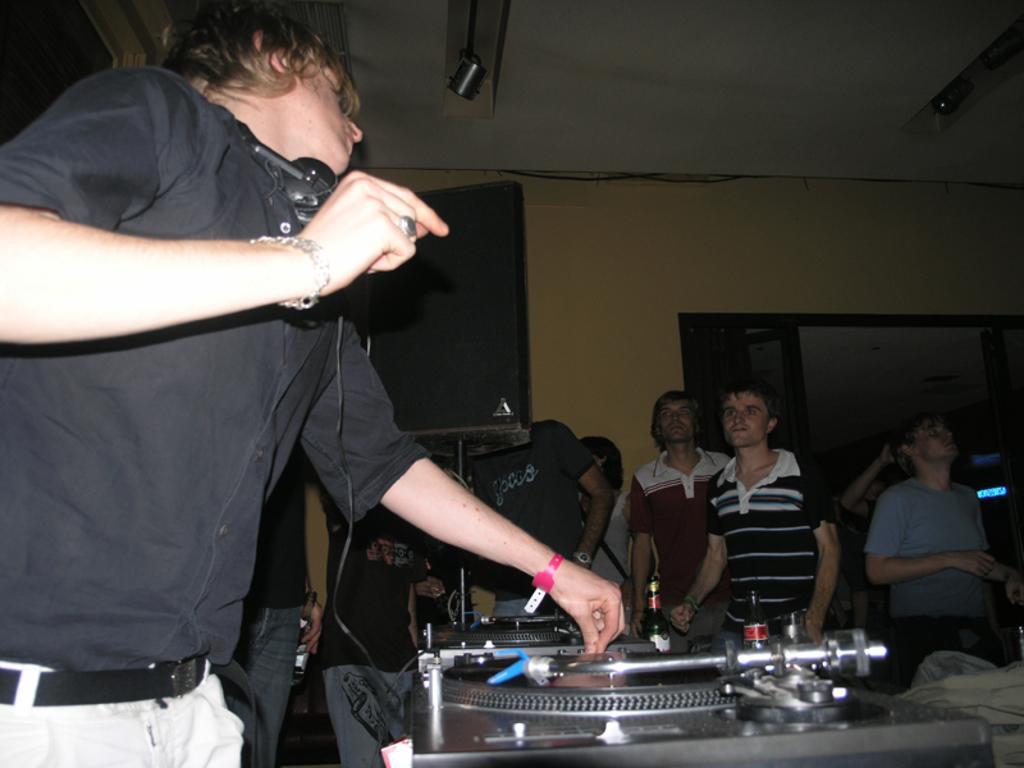How would you summarize this image in a sentence or two? In this image I can see a group of people on the floor and equipments. In the background I can see a wall, speaker stand, door and a rooftop. This image is taken may be in a hall. 